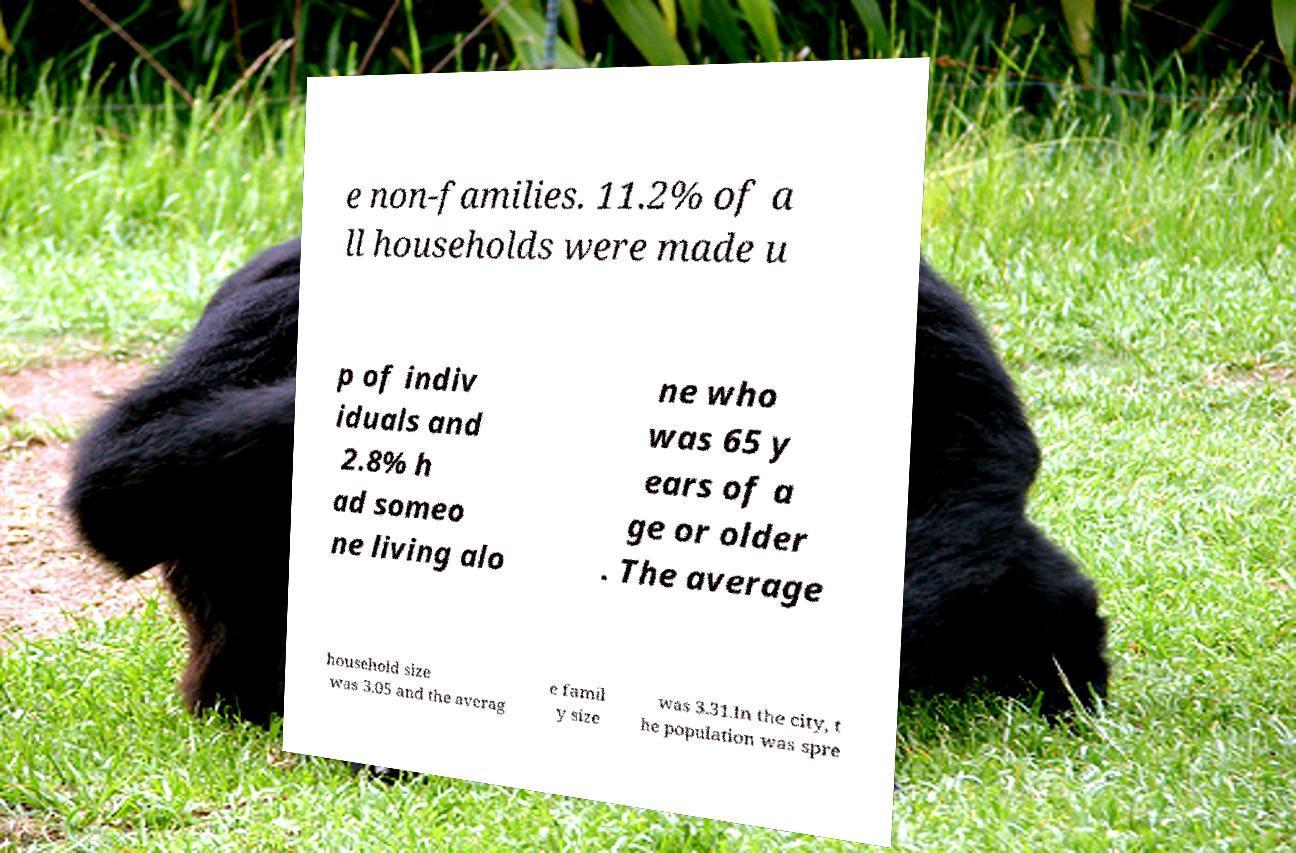There's text embedded in this image that I need extracted. Can you transcribe it verbatim? e non-families. 11.2% of a ll households were made u p of indiv iduals and 2.8% h ad someo ne living alo ne who was 65 y ears of a ge or older . The average household size was 3.05 and the averag e famil y size was 3.31.In the city, t he population was spre 